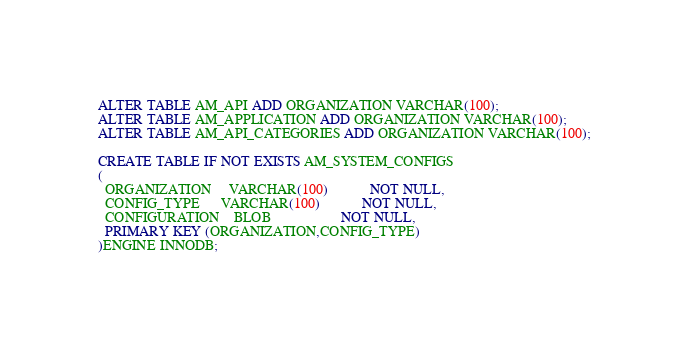Convert code to text. <code><loc_0><loc_0><loc_500><loc_500><_SQL_>ALTER TABLE AM_API ADD ORGANIZATION VARCHAR(100);
ALTER TABLE AM_APPLICATION ADD ORGANIZATION VARCHAR(100);
ALTER TABLE AM_API_CATEGORIES ADD ORGANIZATION VARCHAR(100);

CREATE TABLE IF NOT EXISTS AM_SYSTEM_CONFIGS
(
  ORGANIZATION     VARCHAR(100)            NOT NULL,
  CONFIG_TYPE      VARCHAR(100)            NOT NULL,
  CONFIGURATION    BLOB                    NOT NULL,
  PRIMARY KEY (ORGANIZATION,CONFIG_TYPE)
)ENGINE INNODB;</code> 